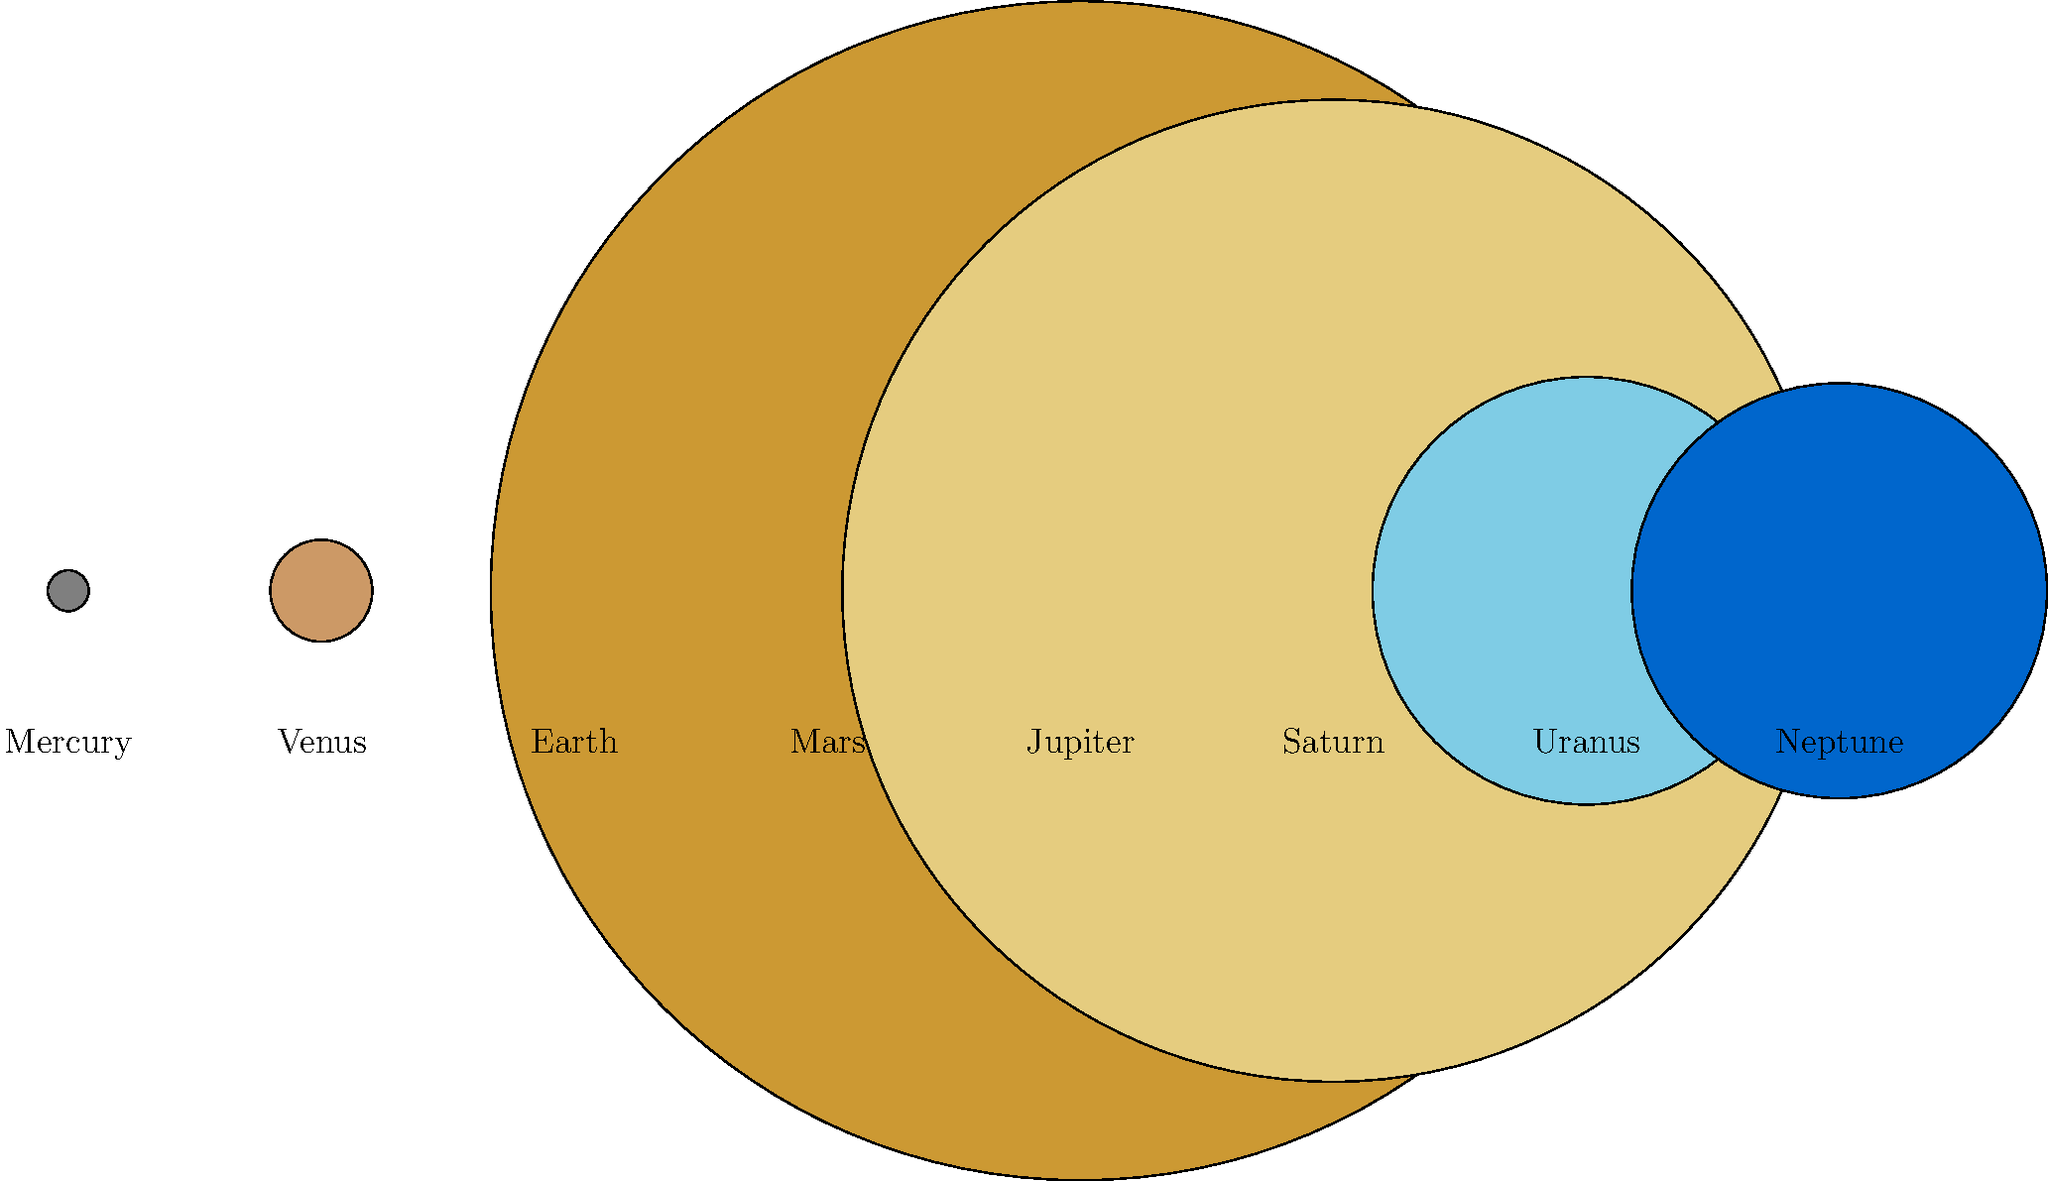In the diagram above, the planets of our solar system are represented by scaled circles. Which planet is represented by the largest circle, and how does its size compare to Furman's home state, South Carolina? Let's approach this step-by-step:

1. Observe the diagram: The circles represent the planets of our solar system, scaled to show their relative sizes.

2. Identify the largest circle: The largest circle in the diagram represents Jupiter, the fifth planet from the sun.

3. Compare Jupiter's size to Earth:
   - Jupiter's diameter: 139,820 km
   - Earth's diameter: 12,742 km
   - Ratio: $\frac{139,820}{12,742} \approx 10.97$

   So Jupiter is about 11 times wider than Earth.

4. Compare to South Carolina:
   - South Carolina's width (east to west): approximately 360 km
   - Jupiter's diameter: 139,820 km
   - Ratio: $\frac{139,820}{360} \approx 388.39$

   Jupiter is about 388 times wider than South Carolina.

5. Visualize: If South Carolina were a basketball on the Furman court, Jupiter would be like a gigantic sphere nearly filling the entire arena!

This comparison shows just how massive Jupiter is, emphasizing the importance of supporting our team no matter the odds, just like how Earth keeps orbiting despite Jupiter's enormous presence in our solar system.
Answer: Jupiter; about 388 times wider than South Carolina 